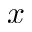Convert formula to latex. <formula><loc_0><loc_0><loc_500><loc_500>x</formula> 